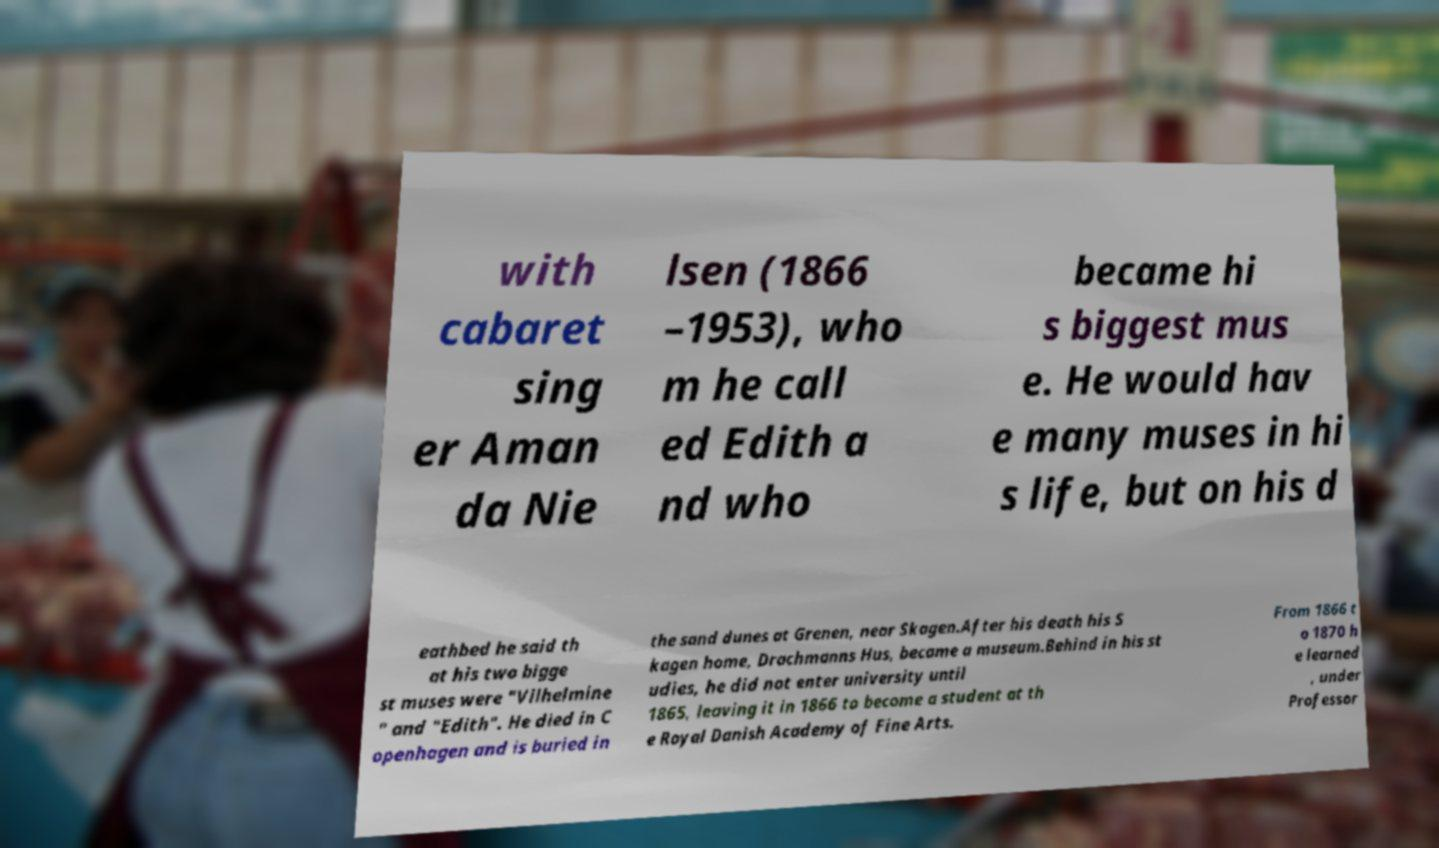For documentation purposes, I need the text within this image transcribed. Could you provide that? with cabaret sing er Aman da Nie lsen (1866 –1953), who m he call ed Edith a nd who became hi s biggest mus e. He would hav e many muses in hi s life, but on his d eathbed he said th at his two bigge st muses were "Vilhelmine " and "Edith". He died in C openhagen and is buried in the sand dunes at Grenen, near Skagen.After his death his S kagen home, Drachmanns Hus, became a museum.Behind in his st udies, he did not enter university until 1865, leaving it in 1866 to become a student at th e Royal Danish Academy of Fine Arts. From 1866 t o 1870 h e learned , under Professor 